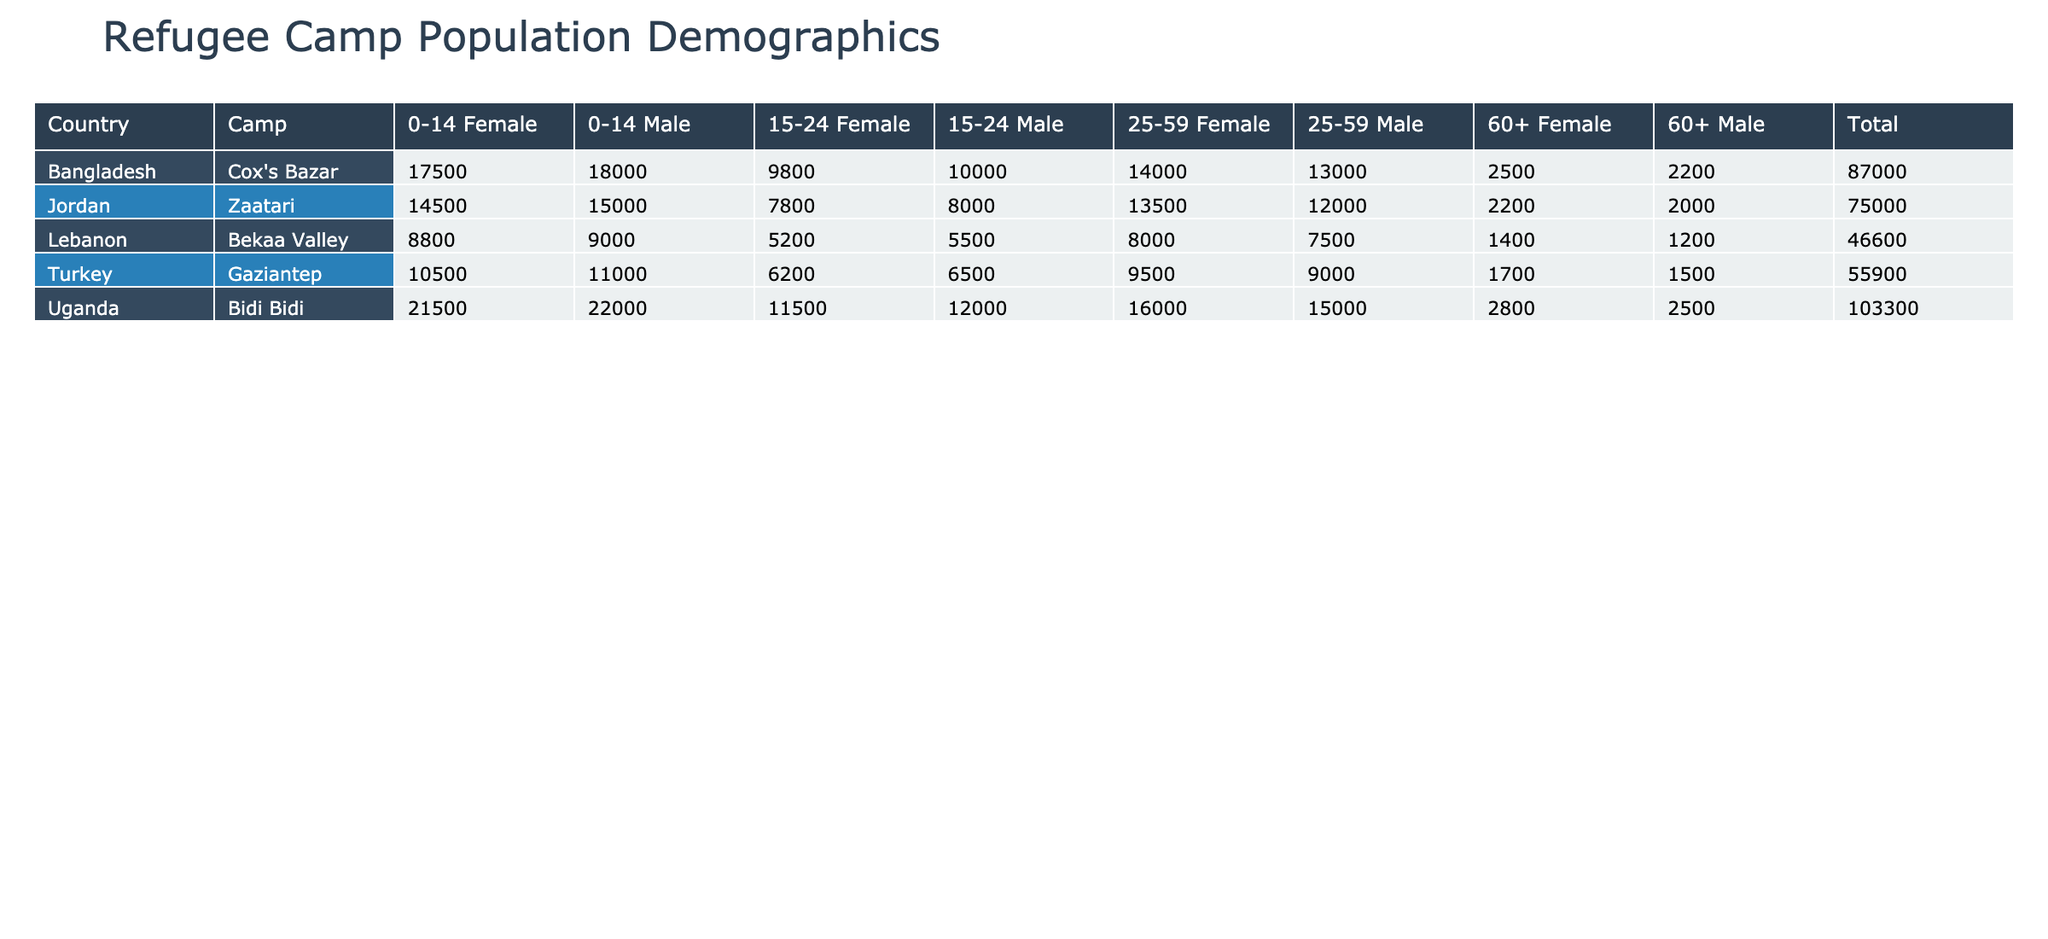What is the total male population in the Zaatari camp? To find the total male population in Zaatari, I need to sum the populations across all age groups for males. The male populations are: 15000 (0-14) + 8000 (15-24) + 12000 (25-59) + 2000 (60+) = 15000 + 8000 + 12000 + 2000 = 33000.
Answer: 33000 What is the total population of the Bidi Bidi camp? For the Bidi Bidi camp, I will sum all the age and gender populations listed. The total is calculated as: 22000 (0-14 Male) + 21500 (0-14 Female) + 12000 (15-24 Male) + 11500 (15-24 Female) + 15000 (25-59 Male) + 16000 (25-59 Female) + 2500 (60+ Male) + 2800 (60+ Female) = 165300.
Answer: 165300 Is the number of females in the Gaziantep camp greater than the number of males? To answer this, I will compare the total female population to the total male population in Gaziantep. The female population totals are: 10500 (0-14) + 6200 (15-24) + 9500 (25-59) + 1700 (60+) = 29500. The male population totals are: 11000 (0-14) + 6500 (15-24) + 9000 (25-59) + 1500 (60+) = 29500. Since both totals are equal, the answer is no.
Answer: No What is the average population of the 0-14 age group across all camps? To find the average population of the 0-14 age group, I first sum the populations of this age group across the different camps. The values are: 15000 (Zaatari Male) + 14500 (Zaatari Female) + 9000 (Bekaa Valley Male) + 8800 (Bekaa Valley Female) + 11000 (Gaziantep Male) + 10500 (Gaziantep Female) + 22000 (Bidi Bidi Male) + 21500 (Bidi Bidi Female) + 18000 (Cox's Bazar Male) + 17500 (Cox's Bazar Female) = 94700. There are 10 data points (5 camps, 2 genders), so the average is 94700 / 10 = 9470.
Answer: 9470 Which camp has the highest total population? To determine which camp has the highest total population, I will calculate the total population for each camp: Zaatari = 15000 + 14500 + 8000 + 7800 + 12000 + 13500 + 2000 + 2200 = 70500, Bekaa Valley = 9000 + 8800 + 5500 + 5200 + 7500 + 8000 + 1200 + 1400 = 39500, Gaziantep = 11000 + 10500 + 6500 + 6200 + 9000 + 9500 + 1500 + 1700 = 52500, Bidi Bidi = 22000 + 21500 + 12000 + 11500 + 15000 + 16000 + 2500 + 2800 = 165300, Cox's Bazar = 18000 + 17500 + 10000 + 9800 + 13000 + 14000 + 2200 + 2500 = 91000. Bidi Bidi has the highest total population of 165300.
Answer: Bidi Bidi 